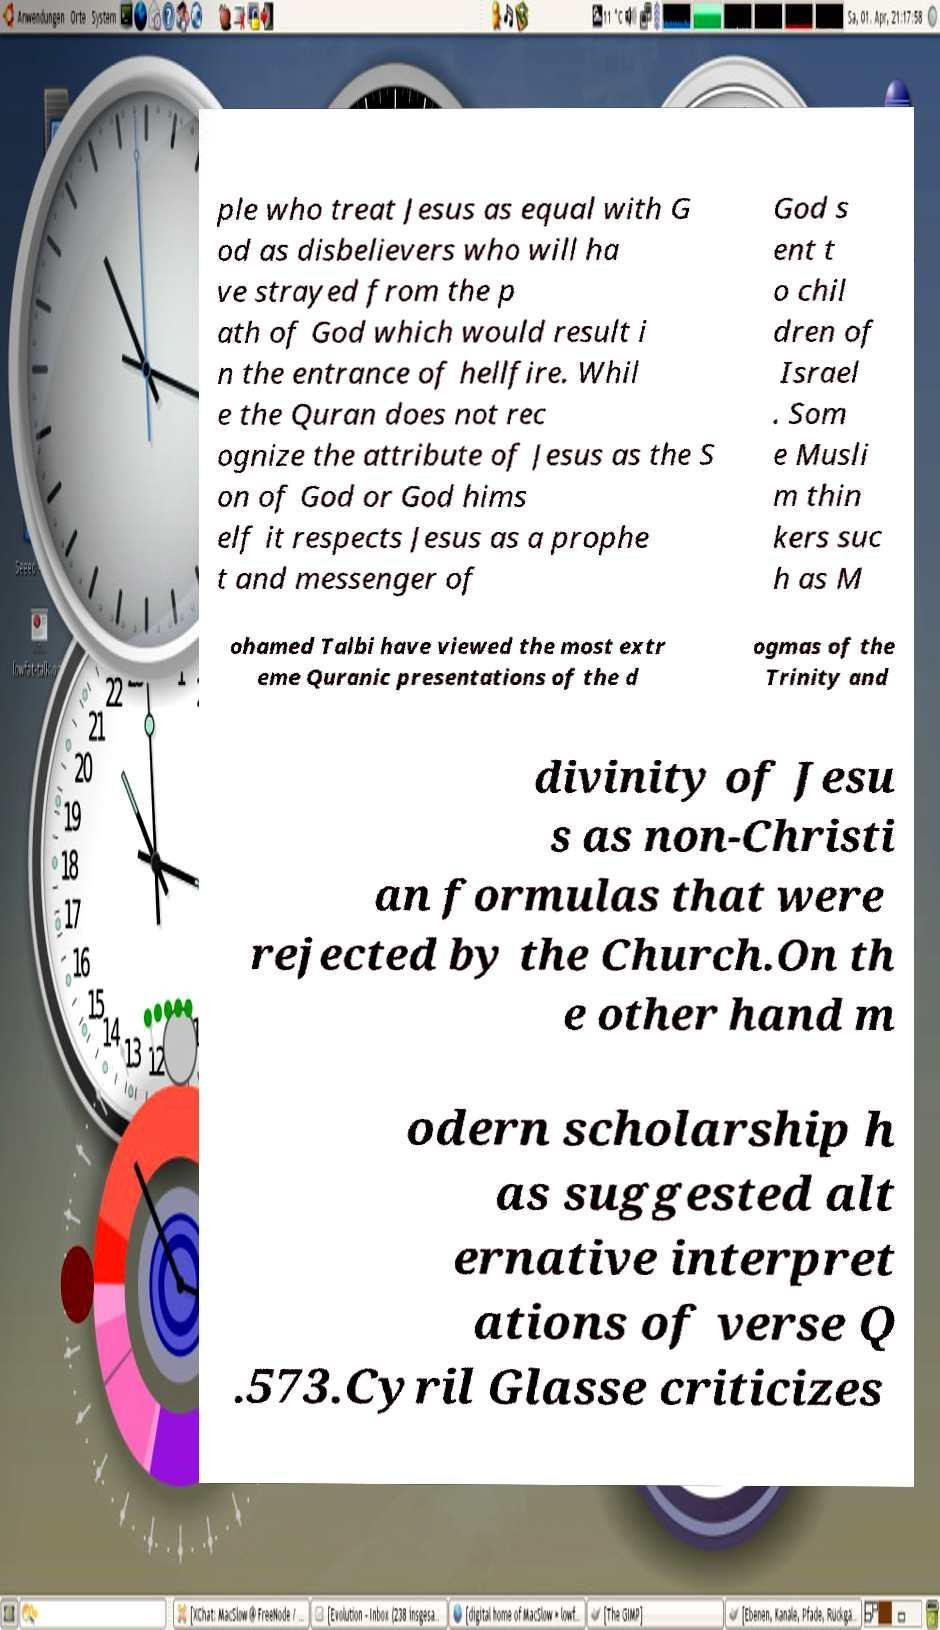For documentation purposes, I need the text within this image transcribed. Could you provide that? ple who treat Jesus as equal with G od as disbelievers who will ha ve strayed from the p ath of God which would result i n the entrance of hellfire. Whil e the Quran does not rec ognize the attribute of Jesus as the S on of God or God hims elf it respects Jesus as a prophe t and messenger of God s ent t o chil dren of Israel . Som e Musli m thin kers suc h as M ohamed Talbi have viewed the most extr eme Quranic presentations of the d ogmas of the Trinity and divinity of Jesu s as non-Christi an formulas that were rejected by the Church.On th e other hand m odern scholarship h as suggested alt ernative interpret ations of verse Q .573.Cyril Glasse criticizes 